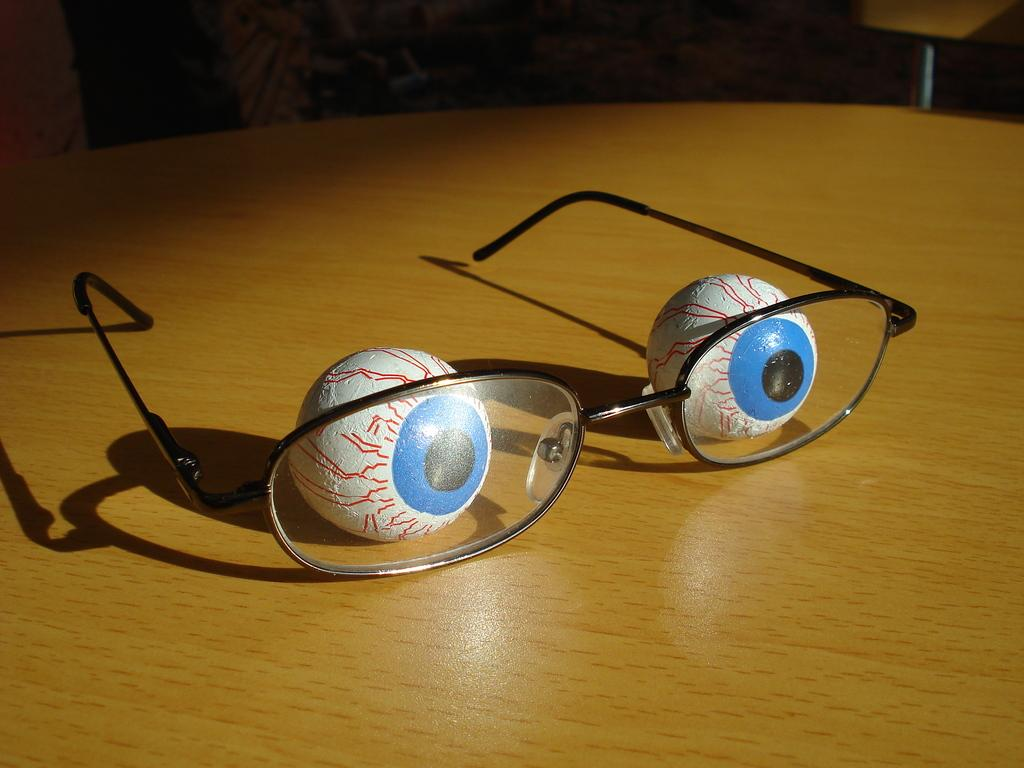What type of object can be seen in the image related to vision? There are spectacles in the image. What other objects are present in the image that appear to be artistic? There are balls with painting in the image. Where are these objects located in the image? These objects are on a table. What type of kite is being flown by the spectacles in the image? There is no kite present in the image, and the spectacles are not flying anything. 